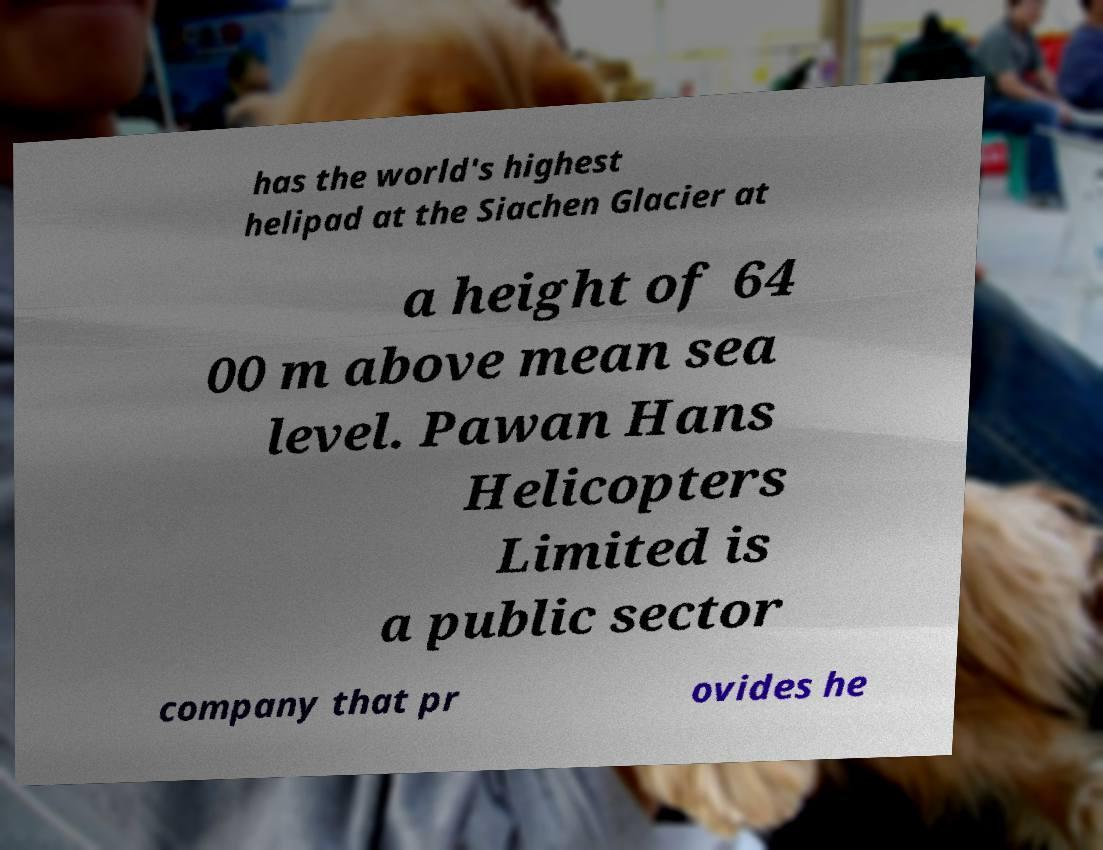Could you assist in decoding the text presented in this image and type it out clearly? has the world's highest helipad at the Siachen Glacier at a height of 64 00 m above mean sea level. Pawan Hans Helicopters Limited is a public sector company that pr ovides he 